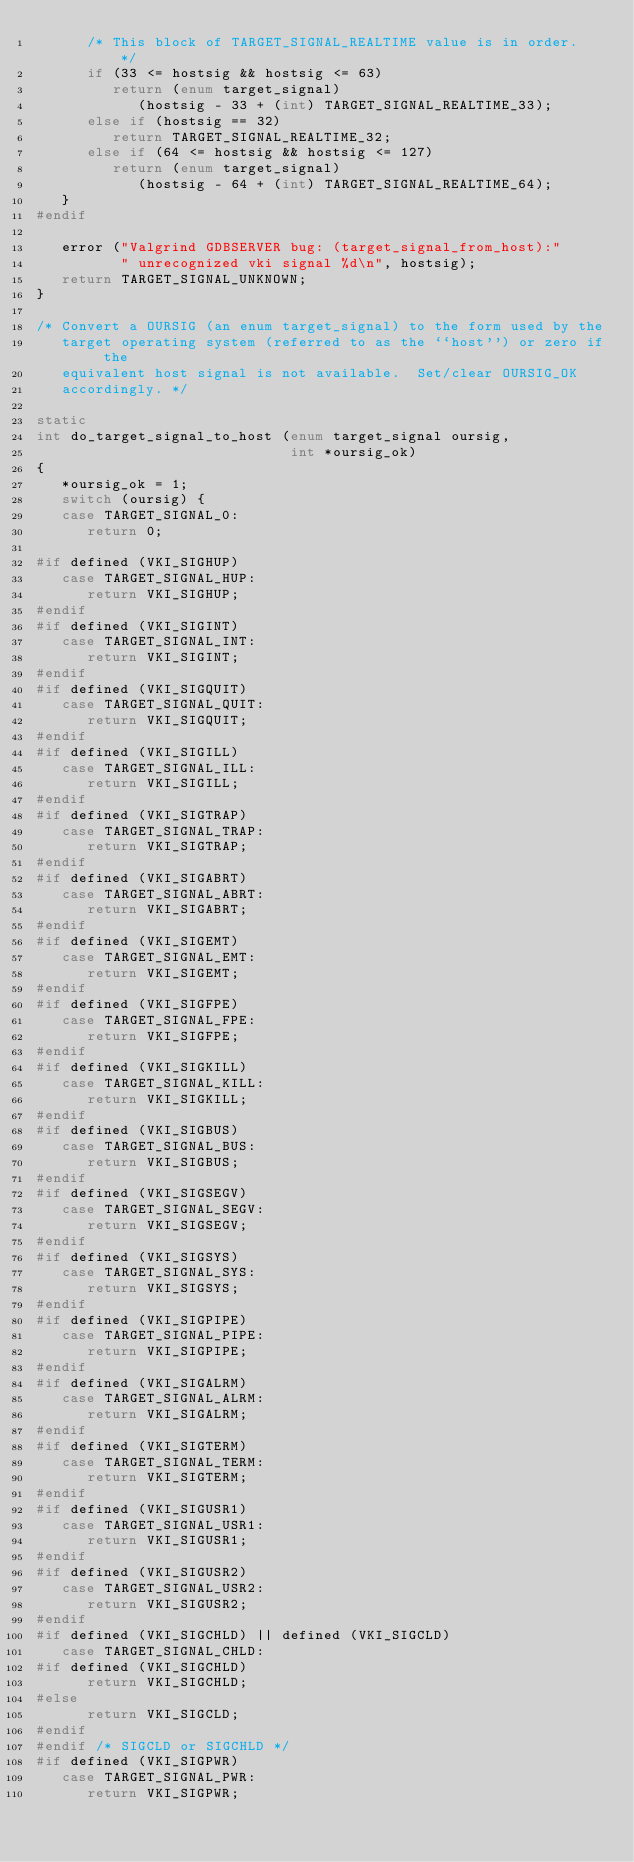Convert code to text. <code><loc_0><loc_0><loc_500><loc_500><_C_>      /* This block of TARGET_SIGNAL_REALTIME value is in order.  */
      if (33 <= hostsig && hostsig <= 63)
         return (enum target_signal)
            (hostsig - 33 + (int) TARGET_SIGNAL_REALTIME_33);
      else if (hostsig == 32)
         return TARGET_SIGNAL_REALTIME_32;
      else if (64 <= hostsig && hostsig <= 127)
         return (enum target_signal)
            (hostsig - 64 + (int) TARGET_SIGNAL_REALTIME_64);
   }
#endif

   error ("Valgrind GDBSERVER bug: (target_signal_from_host):"
          " unrecognized vki signal %d\n", hostsig);
   return TARGET_SIGNAL_UNKNOWN;
}

/* Convert a OURSIG (an enum target_signal) to the form used by the
   target operating system (referred to as the ``host'') or zero if the
   equivalent host signal is not available.  Set/clear OURSIG_OK
   accordingly. */

static
int do_target_signal_to_host (enum target_signal oursig,
                              int *oursig_ok)
{
   *oursig_ok = 1;
   switch (oursig) {
   case TARGET_SIGNAL_0:
      return 0;

#if defined (VKI_SIGHUP)
   case TARGET_SIGNAL_HUP:
      return VKI_SIGHUP;
#endif
#if defined (VKI_SIGINT)
   case TARGET_SIGNAL_INT:
      return VKI_SIGINT;
#endif
#if defined (VKI_SIGQUIT)
   case TARGET_SIGNAL_QUIT:
      return VKI_SIGQUIT;
#endif
#if defined (VKI_SIGILL)
   case TARGET_SIGNAL_ILL:
      return VKI_SIGILL;
#endif
#if defined (VKI_SIGTRAP)
   case TARGET_SIGNAL_TRAP:
      return VKI_SIGTRAP;
#endif
#if defined (VKI_SIGABRT)
   case TARGET_SIGNAL_ABRT:
      return VKI_SIGABRT;
#endif
#if defined (VKI_SIGEMT)
   case TARGET_SIGNAL_EMT:
      return VKI_SIGEMT;
#endif
#if defined (VKI_SIGFPE)
   case TARGET_SIGNAL_FPE:
      return VKI_SIGFPE;
#endif
#if defined (VKI_SIGKILL)
   case TARGET_SIGNAL_KILL:
      return VKI_SIGKILL;
#endif
#if defined (VKI_SIGBUS)
   case TARGET_SIGNAL_BUS:
      return VKI_SIGBUS;
#endif
#if defined (VKI_SIGSEGV)
   case TARGET_SIGNAL_SEGV:
      return VKI_SIGSEGV;
#endif
#if defined (VKI_SIGSYS)
   case TARGET_SIGNAL_SYS:
      return VKI_SIGSYS;
#endif
#if defined (VKI_SIGPIPE)
   case TARGET_SIGNAL_PIPE:
      return VKI_SIGPIPE;
#endif
#if defined (VKI_SIGALRM)
   case TARGET_SIGNAL_ALRM:
      return VKI_SIGALRM;
#endif
#if defined (VKI_SIGTERM)
   case TARGET_SIGNAL_TERM:
      return VKI_SIGTERM;
#endif
#if defined (VKI_SIGUSR1)
   case TARGET_SIGNAL_USR1:
      return VKI_SIGUSR1;
#endif
#if defined (VKI_SIGUSR2)
   case TARGET_SIGNAL_USR2:
      return VKI_SIGUSR2;
#endif
#if defined (VKI_SIGCHLD) || defined (VKI_SIGCLD)
   case TARGET_SIGNAL_CHLD:
#if defined (VKI_SIGCHLD)
      return VKI_SIGCHLD;
#else
      return VKI_SIGCLD;
#endif
#endif /* SIGCLD or SIGCHLD */
#if defined (VKI_SIGPWR)
   case TARGET_SIGNAL_PWR:
      return VKI_SIGPWR;</code> 